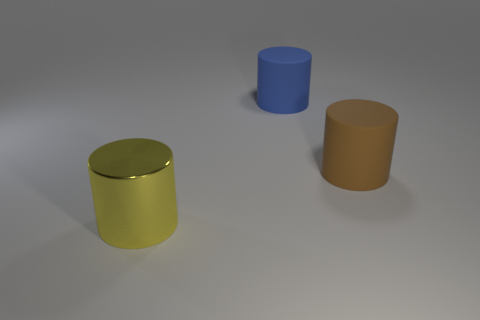There is a big cylinder that is right of the blue thing; does it have the same color as the cylinder to the left of the large blue cylinder?
Your response must be concise. No. How many matte cylinders are both on the left side of the big brown cylinder and in front of the large blue cylinder?
Ensure brevity in your answer.  0. How many other objects are the same shape as the large brown thing?
Keep it short and to the point. 2. Is the number of large blue matte things right of the big blue object greater than the number of brown matte cylinders?
Ensure brevity in your answer.  No. What is the color of the rubber cylinder that is in front of the large blue matte cylinder?
Provide a short and direct response. Brown. How many rubber things are purple cylinders or big blue objects?
Provide a short and direct response. 1. Is there a brown matte thing that is on the left side of the large cylinder that is behind the rubber cylinder in front of the blue cylinder?
Provide a short and direct response. No. There is a big brown rubber cylinder; what number of big cylinders are left of it?
Give a very brief answer. 2. What number of tiny objects are either blue cylinders or yellow metal cylinders?
Provide a succinct answer. 0. There is a big matte thing behind the large brown cylinder; what shape is it?
Provide a succinct answer. Cylinder. 